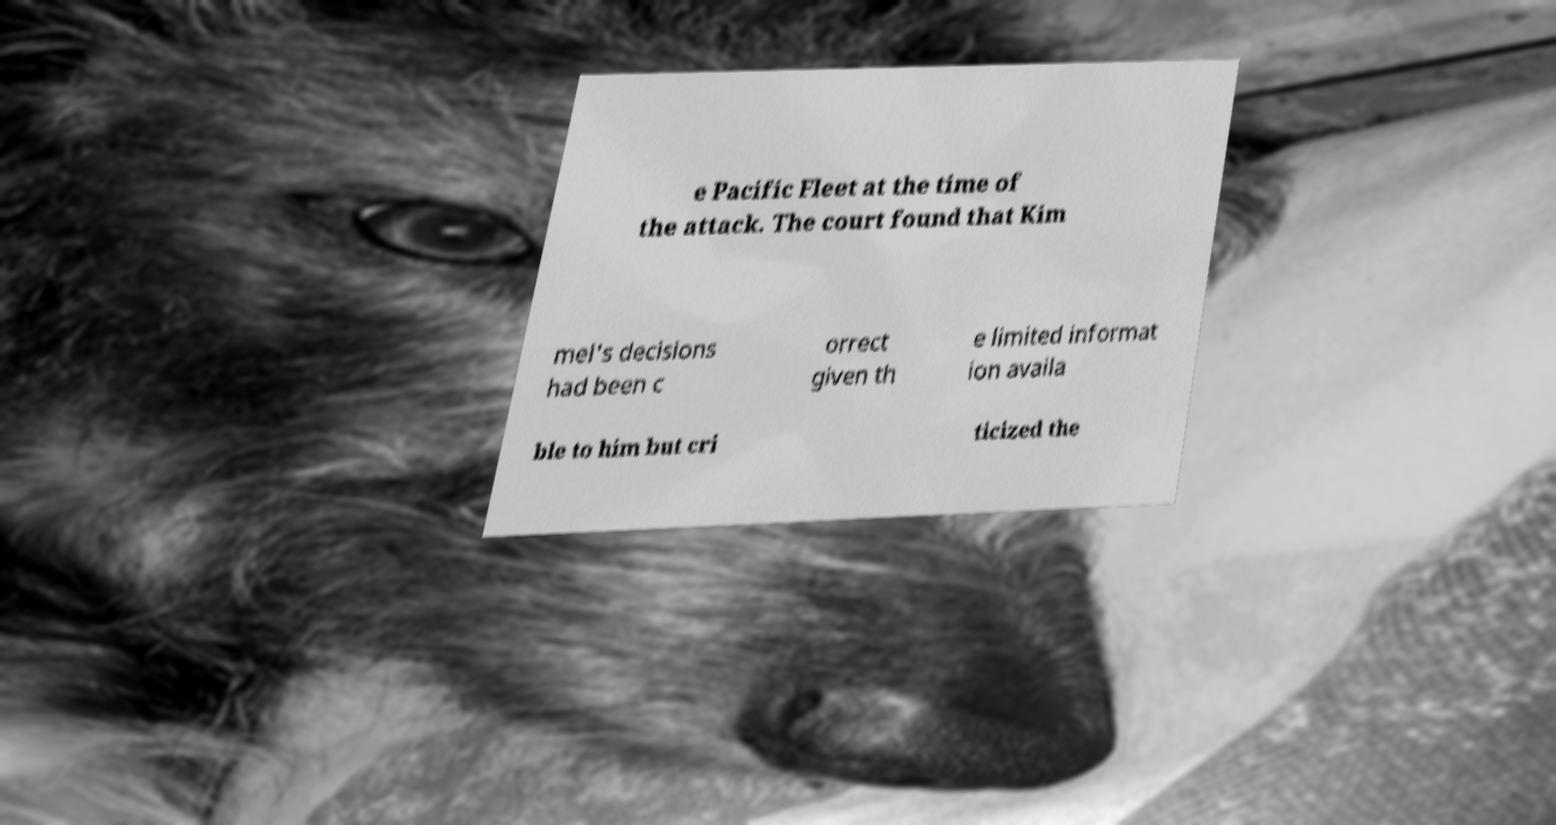Can you read and provide the text displayed in the image?This photo seems to have some interesting text. Can you extract and type it out for me? e Pacific Fleet at the time of the attack. The court found that Kim mel's decisions had been c orrect given th e limited informat ion availa ble to him but cri ticized the 